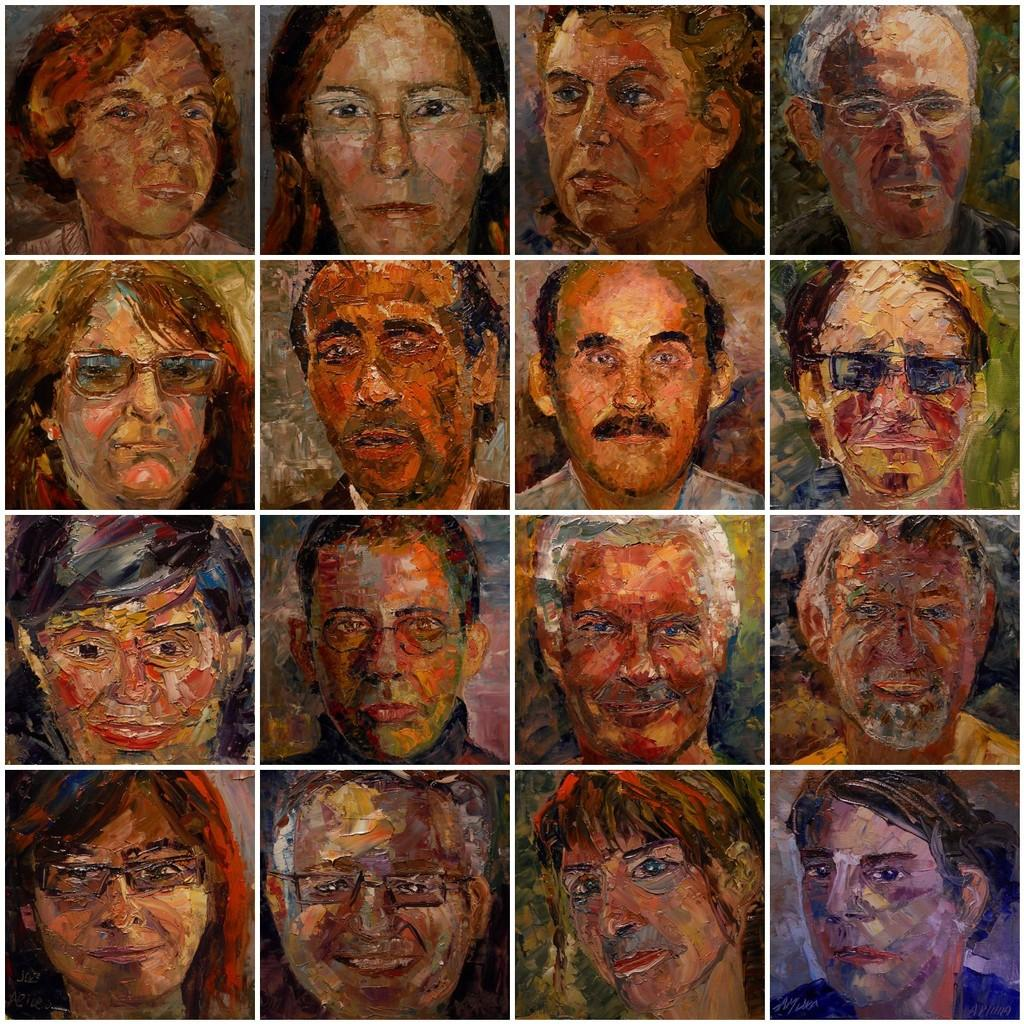What is the main subject of the image? The main subject of the image is a depiction of people's faces. Can you describe the faces in the image? Unfortunately, the facts provided do not give any details about the faces in the image. Are there any other elements in the image besides the faces? The facts provided do not mention any other elements in the image. What type of debt is being discussed in the image? There is no mention of debt in the image, as it only depicts people's faces. How does the note affect the care provided in the image? There is no note or care mentioned in the image, as it only depicts people's faces. 